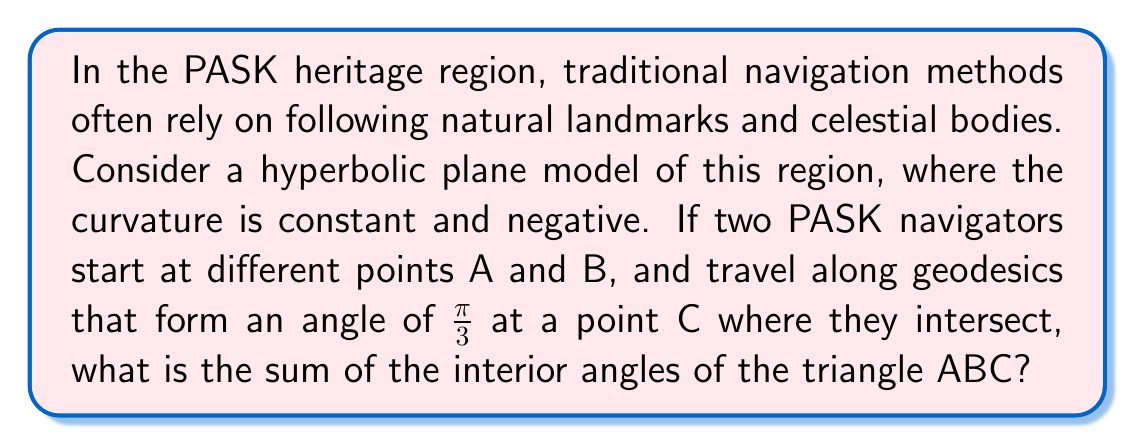Can you solve this math problem? Let's approach this step-by-step:

1) In Euclidean geometry, the sum of interior angles of a triangle is always $\pi$ radians or 180°. However, in hyperbolic geometry, this sum is always less than $\pi$.

2) In a hyperbolic plane, the defect of a triangle is defined as the difference between $\pi$ and the sum of its interior angles. This defect is directly proportional to the area of the triangle.

3) The relationship between the area $A$ of a hyperbolic triangle and its angle sum $\sum \theta$ is given by the Gauss-Bonnet formula:

   $$A = |\kappa|(\pi - \sum \theta)$$

   where $\kappa$ is the Gaussian curvature of the hyperbolic plane.

4) We're not given the specific area or curvature, but we know one of the angles is $\frac{\pi}{3}$.

5) Let's denote the other two angles as $\alpha$ and $\beta$. We can write:

   $$\alpha + \beta + \frac{\pi}{3} < \pi$$

6) The exact values of $\alpha$ and $\beta$ depend on the specific geometry of the triangle, which we don't know. However, we can say that their sum must be less than $\frac{2\pi}{3}$.

7) This aligns with the PASK navigation methods, where travelers would need to account for the curvature of the land in their journeys, much like how we account for the curvature of the hyperbolic plane in this problem.

Therefore, while we can't determine the exact sum, we can conclude that the sum of the interior angles of the triangle ABC is less than $\pi$ radians or 180°, but greater than $\frac{\pi}{3}$ radians or 60°.
Answer: $\frac{\pi}{3} < \sum \theta < \pi$ 